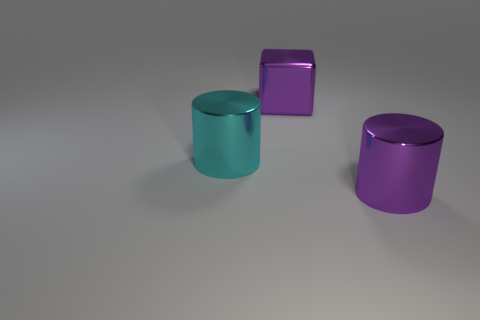The big cyan object has what shape?
Give a very brief answer. Cylinder. There is a cylinder on the right side of the purple thing that is behind the purple shiny cylinder; what color is it?
Offer a very short reply. Purple. What is the size of the cyan object left of the purple metallic cylinder?
Offer a very short reply. Large. Are there any small purple spheres that have the same material as the block?
Keep it short and to the point. No. What number of green metallic objects have the same shape as the large cyan thing?
Your answer should be compact. 0. There is a object that is on the left side of the purple metallic thing that is left of the large shiny object to the right of the purple metal cube; what is its shape?
Give a very brief answer. Cylinder. There is a large thing that is both on the right side of the cyan object and in front of the large metal block; what material is it made of?
Provide a succinct answer. Metal. There is a purple object that is on the left side of the purple metallic cylinder; is its size the same as the purple metallic cylinder?
Your answer should be very brief. Yes. Are there any other things that have the same size as the purple cube?
Give a very brief answer. Yes. Is the number of large metallic things that are in front of the purple metal block greater than the number of big metal cylinders behind the cyan thing?
Give a very brief answer. Yes. 